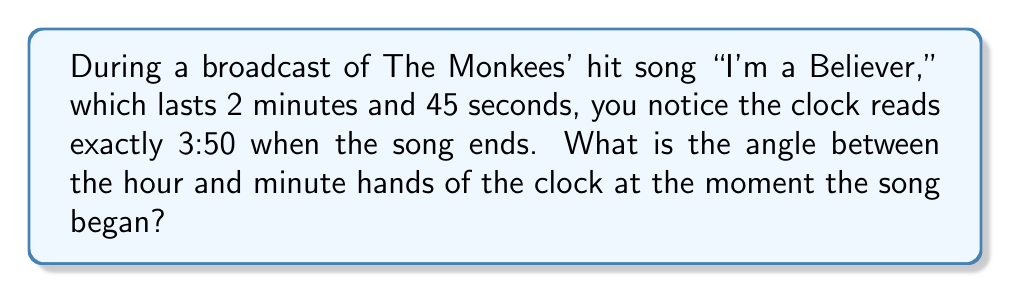Teach me how to tackle this problem. Let's approach this step-by-step:

1) First, we need to determine the time when the song began. 
   The song ended at 3:50, and it lasted 2 minutes and 45 seconds.
   So, the song started at 3:47:15 (3 hours, 47 minutes, and 15 seconds).

2) Now, let's calculate the angle for each hand:

   Hour hand:
   - In 12 hours, the hour hand rotates 360°
   - In 1 hour, it rotates 360° ÷ 12 = 30°
   - In 1 minute, it rotates 30° ÷ 60 = 0.5°
   
   At 3:47:15, the hour hand has moved:
   $$(3 \times 30°) + (47 \times 0.5°) + (15 \times \frac{0.5}{60}°) = 90° + 23.5° + 0.125° = 113.625°$$

   Minute hand:
   - In 60 minutes, the minute hand rotates 360°
   - In 1 minute, it rotates 360° ÷ 60 = 6°
   - In 1 second, it rotates 6° ÷ 60 = 0.1°
   
   At 47 minutes and 15 seconds past the hour:
   $$(47 \times 6°) + (15 \times 0.1°) = 282° + 1.5° = 283.5°$$

3) The angle between the hands is the absolute difference:
   $$|283.5° - 113.625°| = 169.875°$$

4) However, if this angle is greater than 180°, we need to subtract it from 360° to get the smaller angle between the hands:
   $$360° - 169.875° = 190.125°$$

5) The smaller angle is 169.875°.
Answer: 169.875° 